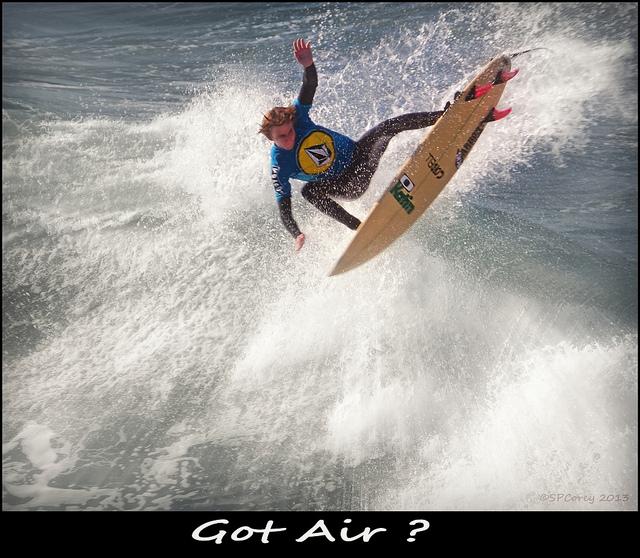Where is the man surfing?
Short answer required. Ocean. What is the man standing on?
Give a very brief answer. Surfboard. What is the caption at the bottom of the image?
Keep it brief. Got air?. 